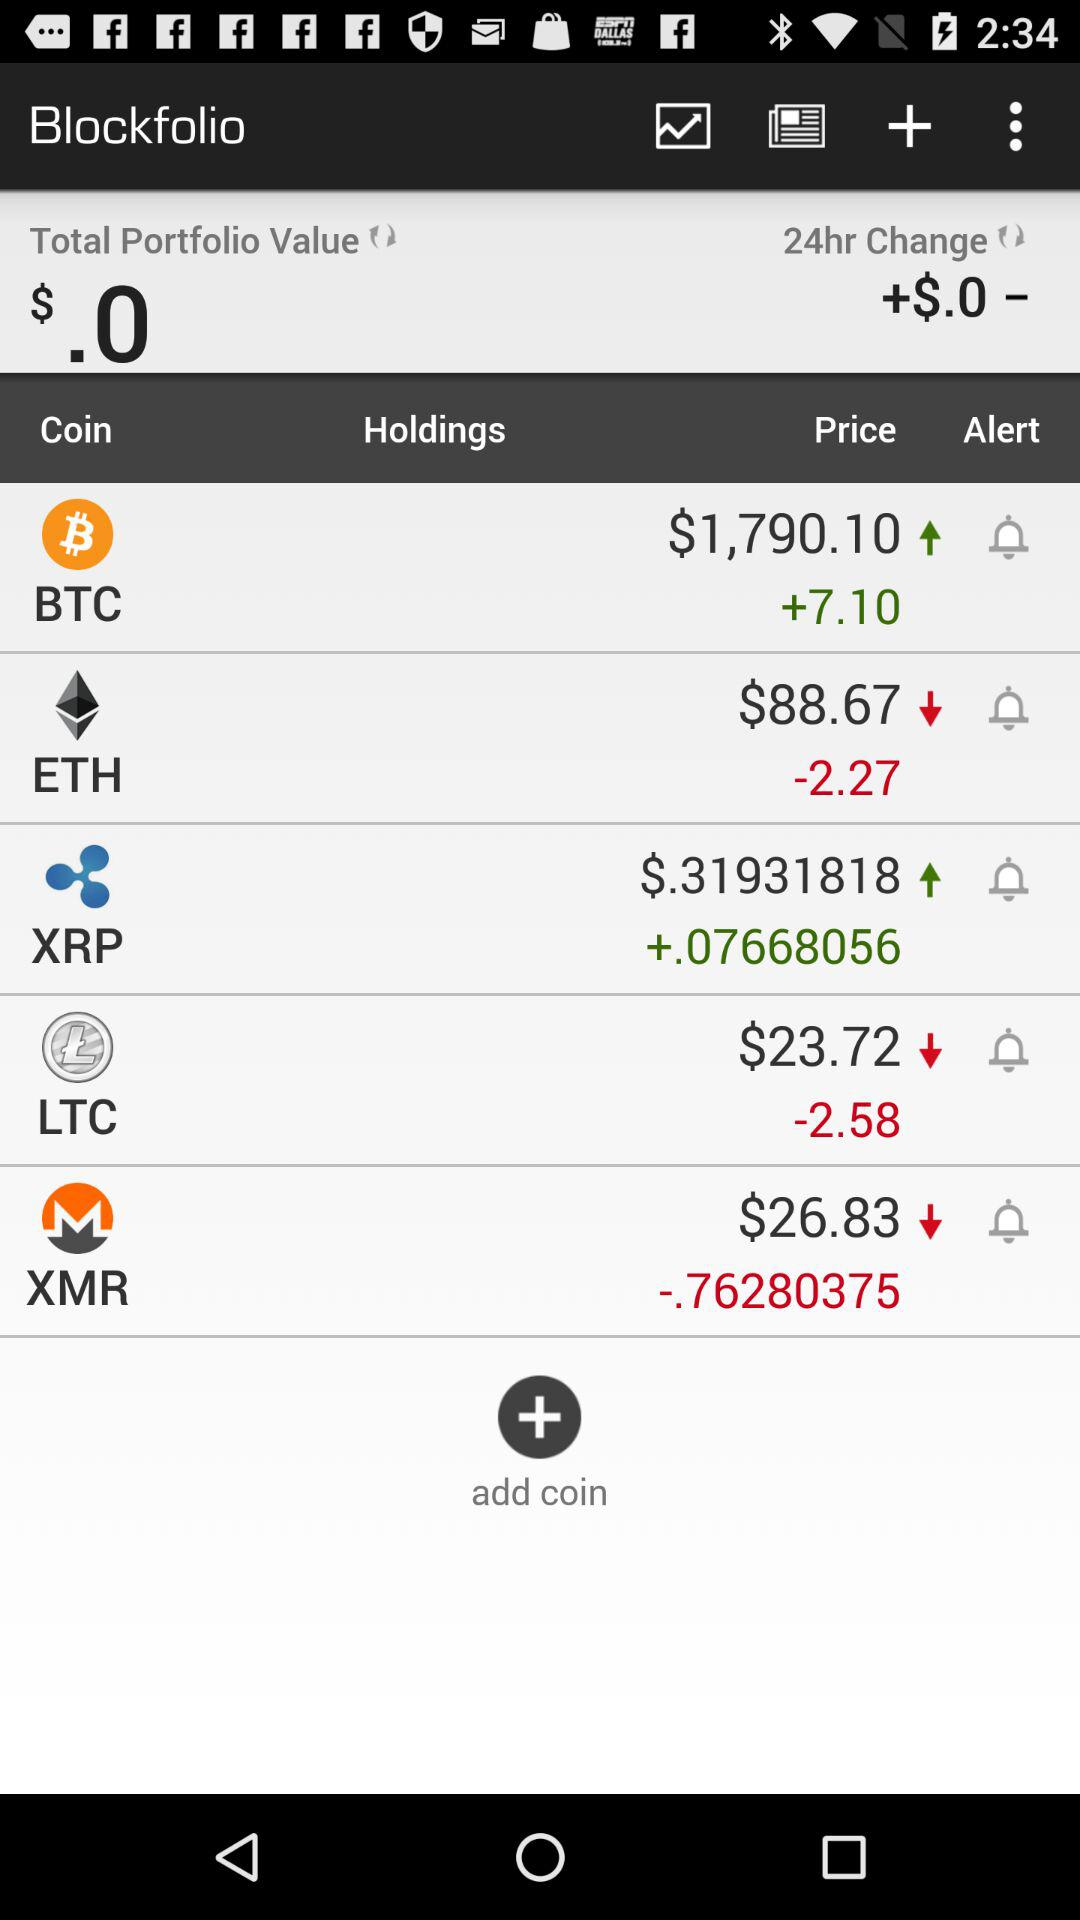What is the price of BTC? The price of BTC is $1,790.10. 